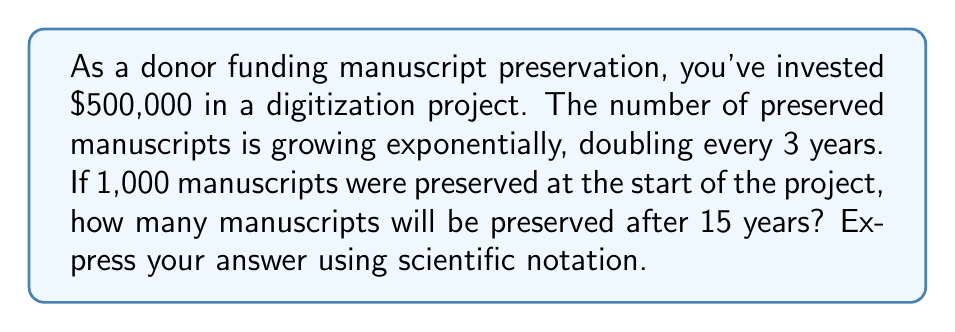Can you answer this question? To solve this problem, we need to use the exponential growth formula:

$$A = P(1 + r)^t$$

Where:
$A$ = Final amount
$P$ = Initial amount (1,000 manuscripts)
$r$ = Growth rate
$t$ = Time (15 years)

First, we need to find the growth rate $r$. We know the number of manuscripts doubles every 3 years, so:

$$2 = (1 + r)^3$$

Taking the cube root of both sides:

$$(2)^{\frac{1}{3}} = 1 + r$$

$$r = (2)^{\frac{1}{3}} - 1 \approx 0.2599 \text{ or } 25.99\%$$

Now we can plug this into our exponential growth formula:

$$A = 1000(1 + 0.2599)^{\frac{15}{3}}$$

We divide 15 by 3 because the growth rate is per 3-year period.

$$A = 1000(1.2599)^5$$

Using a calculator:

$$A = 1000 \times 3.17866 = 3178.66$$

Rounding to the nearest whole number: 3,179 manuscripts
Answer: $3.18 \times 10^3$ manuscripts 